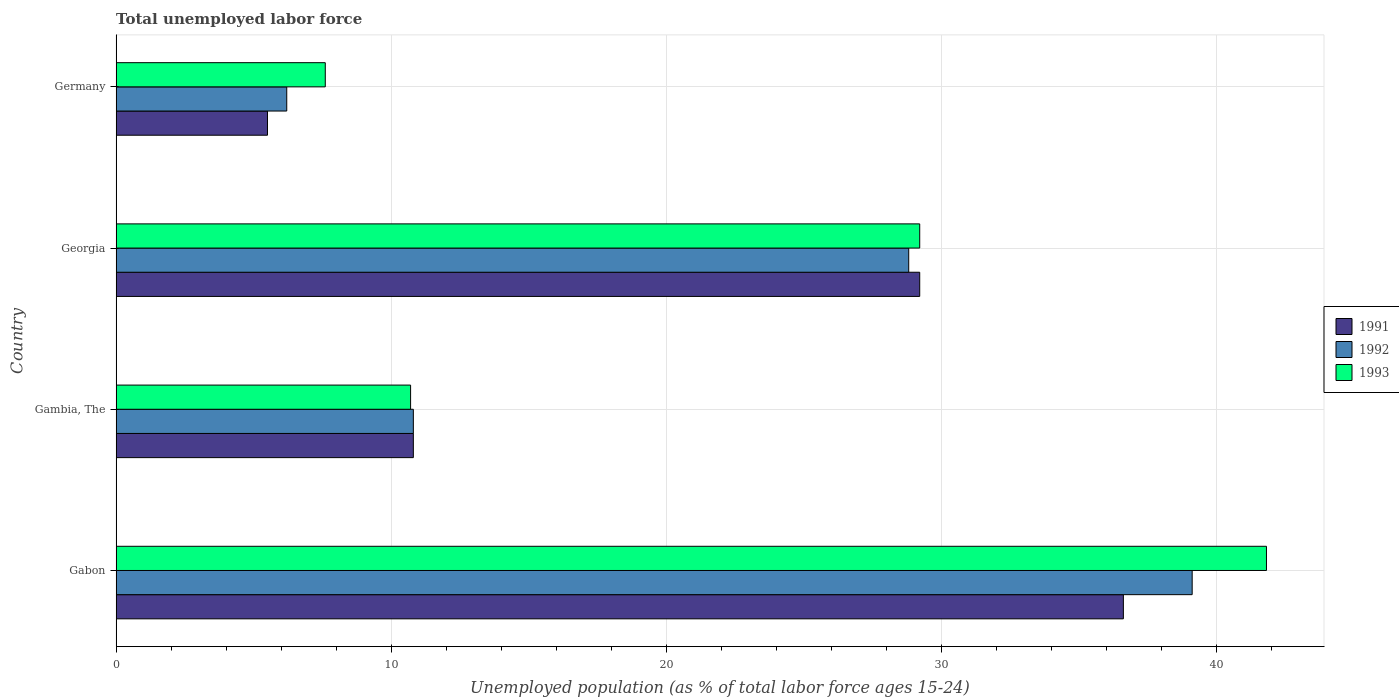How many groups of bars are there?
Your response must be concise. 4. Are the number of bars on each tick of the Y-axis equal?
Offer a very short reply. Yes. How many bars are there on the 4th tick from the top?
Your answer should be very brief. 3. What is the label of the 4th group of bars from the top?
Provide a short and direct response. Gabon. What is the percentage of unemployed population in in 1993 in Georgia?
Ensure brevity in your answer.  29.2. Across all countries, what is the maximum percentage of unemployed population in in 1991?
Ensure brevity in your answer.  36.6. In which country was the percentage of unemployed population in in 1992 maximum?
Your answer should be very brief. Gabon. In which country was the percentage of unemployed population in in 1992 minimum?
Provide a short and direct response. Germany. What is the total percentage of unemployed population in in 1993 in the graph?
Your answer should be very brief. 89.3. What is the difference between the percentage of unemployed population in in 1992 in Georgia and that in Germany?
Your response must be concise. 22.6. What is the difference between the percentage of unemployed population in in 1993 in Gambia, The and the percentage of unemployed population in in 1992 in Gabon?
Provide a short and direct response. -28.4. What is the average percentage of unemployed population in in 1991 per country?
Keep it short and to the point. 20.52. What is the difference between the percentage of unemployed population in in 1992 and percentage of unemployed population in in 1993 in Gambia, The?
Your answer should be very brief. 0.1. In how many countries, is the percentage of unemployed population in in 1993 greater than 40 %?
Provide a succinct answer. 1. What is the ratio of the percentage of unemployed population in in 1991 in Gambia, The to that in Georgia?
Provide a short and direct response. 0.37. Is the percentage of unemployed population in in 1991 in Gambia, The less than that in Georgia?
Give a very brief answer. Yes. What is the difference between the highest and the second highest percentage of unemployed population in in 1992?
Your answer should be very brief. 10.3. What is the difference between the highest and the lowest percentage of unemployed population in in 1993?
Provide a short and direct response. 34.2. In how many countries, is the percentage of unemployed population in in 1993 greater than the average percentage of unemployed population in in 1993 taken over all countries?
Your answer should be very brief. 2. What does the 2nd bar from the bottom in Germany represents?
Offer a terse response. 1992. Is it the case that in every country, the sum of the percentage of unemployed population in in 1991 and percentage of unemployed population in in 1993 is greater than the percentage of unemployed population in in 1992?
Provide a short and direct response. Yes. How many bars are there?
Provide a succinct answer. 12. Are all the bars in the graph horizontal?
Your answer should be compact. Yes. What is the difference between two consecutive major ticks on the X-axis?
Offer a very short reply. 10. Does the graph contain any zero values?
Provide a succinct answer. No. Where does the legend appear in the graph?
Offer a terse response. Center right. What is the title of the graph?
Offer a terse response. Total unemployed labor force. Does "2008" appear as one of the legend labels in the graph?
Offer a very short reply. No. What is the label or title of the X-axis?
Offer a terse response. Unemployed population (as % of total labor force ages 15-24). What is the label or title of the Y-axis?
Give a very brief answer. Country. What is the Unemployed population (as % of total labor force ages 15-24) in 1991 in Gabon?
Make the answer very short. 36.6. What is the Unemployed population (as % of total labor force ages 15-24) in 1992 in Gabon?
Provide a succinct answer. 39.1. What is the Unemployed population (as % of total labor force ages 15-24) in 1993 in Gabon?
Provide a short and direct response. 41.8. What is the Unemployed population (as % of total labor force ages 15-24) of 1991 in Gambia, The?
Keep it short and to the point. 10.8. What is the Unemployed population (as % of total labor force ages 15-24) of 1992 in Gambia, The?
Offer a terse response. 10.8. What is the Unemployed population (as % of total labor force ages 15-24) of 1993 in Gambia, The?
Your response must be concise. 10.7. What is the Unemployed population (as % of total labor force ages 15-24) of 1991 in Georgia?
Give a very brief answer. 29.2. What is the Unemployed population (as % of total labor force ages 15-24) of 1992 in Georgia?
Your answer should be compact. 28.8. What is the Unemployed population (as % of total labor force ages 15-24) of 1993 in Georgia?
Your answer should be compact. 29.2. What is the Unemployed population (as % of total labor force ages 15-24) of 1991 in Germany?
Offer a very short reply. 5.5. What is the Unemployed population (as % of total labor force ages 15-24) of 1992 in Germany?
Ensure brevity in your answer.  6.2. What is the Unemployed population (as % of total labor force ages 15-24) of 1993 in Germany?
Keep it short and to the point. 7.6. Across all countries, what is the maximum Unemployed population (as % of total labor force ages 15-24) of 1991?
Give a very brief answer. 36.6. Across all countries, what is the maximum Unemployed population (as % of total labor force ages 15-24) of 1992?
Your response must be concise. 39.1. Across all countries, what is the maximum Unemployed population (as % of total labor force ages 15-24) of 1993?
Keep it short and to the point. 41.8. Across all countries, what is the minimum Unemployed population (as % of total labor force ages 15-24) of 1992?
Offer a very short reply. 6.2. Across all countries, what is the minimum Unemployed population (as % of total labor force ages 15-24) in 1993?
Give a very brief answer. 7.6. What is the total Unemployed population (as % of total labor force ages 15-24) in 1991 in the graph?
Make the answer very short. 82.1. What is the total Unemployed population (as % of total labor force ages 15-24) in 1992 in the graph?
Keep it short and to the point. 84.9. What is the total Unemployed population (as % of total labor force ages 15-24) of 1993 in the graph?
Offer a very short reply. 89.3. What is the difference between the Unemployed population (as % of total labor force ages 15-24) of 1991 in Gabon and that in Gambia, The?
Your answer should be very brief. 25.8. What is the difference between the Unemployed population (as % of total labor force ages 15-24) in 1992 in Gabon and that in Gambia, The?
Provide a short and direct response. 28.3. What is the difference between the Unemployed population (as % of total labor force ages 15-24) in 1993 in Gabon and that in Gambia, The?
Ensure brevity in your answer.  31.1. What is the difference between the Unemployed population (as % of total labor force ages 15-24) in 1991 in Gabon and that in Georgia?
Your response must be concise. 7.4. What is the difference between the Unemployed population (as % of total labor force ages 15-24) in 1991 in Gabon and that in Germany?
Your answer should be very brief. 31.1. What is the difference between the Unemployed population (as % of total labor force ages 15-24) of 1992 in Gabon and that in Germany?
Your answer should be compact. 32.9. What is the difference between the Unemployed population (as % of total labor force ages 15-24) in 1993 in Gabon and that in Germany?
Give a very brief answer. 34.2. What is the difference between the Unemployed population (as % of total labor force ages 15-24) of 1991 in Gambia, The and that in Georgia?
Give a very brief answer. -18.4. What is the difference between the Unemployed population (as % of total labor force ages 15-24) in 1993 in Gambia, The and that in Georgia?
Your answer should be compact. -18.5. What is the difference between the Unemployed population (as % of total labor force ages 15-24) of 1991 in Gambia, The and that in Germany?
Provide a succinct answer. 5.3. What is the difference between the Unemployed population (as % of total labor force ages 15-24) of 1991 in Georgia and that in Germany?
Ensure brevity in your answer.  23.7. What is the difference between the Unemployed population (as % of total labor force ages 15-24) of 1992 in Georgia and that in Germany?
Your response must be concise. 22.6. What is the difference between the Unemployed population (as % of total labor force ages 15-24) of 1993 in Georgia and that in Germany?
Provide a succinct answer. 21.6. What is the difference between the Unemployed population (as % of total labor force ages 15-24) in 1991 in Gabon and the Unemployed population (as % of total labor force ages 15-24) in 1992 in Gambia, The?
Your response must be concise. 25.8. What is the difference between the Unemployed population (as % of total labor force ages 15-24) in 1991 in Gabon and the Unemployed population (as % of total labor force ages 15-24) in 1993 in Gambia, The?
Your response must be concise. 25.9. What is the difference between the Unemployed population (as % of total labor force ages 15-24) in 1992 in Gabon and the Unemployed population (as % of total labor force ages 15-24) in 1993 in Gambia, The?
Provide a succinct answer. 28.4. What is the difference between the Unemployed population (as % of total labor force ages 15-24) of 1991 in Gabon and the Unemployed population (as % of total labor force ages 15-24) of 1992 in Georgia?
Give a very brief answer. 7.8. What is the difference between the Unemployed population (as % of total labor force ages 15-24) of 1991 in Gabon and the Unemployed population (as % of total labor force ages 15-24) of 1993 in Georgia?
Keep it short and to the point. 7.4. What is the difference between the Unemployed population (as % of total labor force ages 15-24) of 1992 in Gabon and the Unemployed population (as % of total labor force ages 15-24) of 1993 in Georgia?
Make the answer very short. 9.9. What is the difference between the Unemployed population (as % of total labor force ages 15-24) in 1991 in Gabon and the Unemployed population (as % of total labor force ages 15-24) in 1992 in Germany?
Keep it short and to the point. 30.4. What is the difference between the Unemployed population (as % of total labor force ages 15-24) in 1992 in Gabon and the Unemployed population (as % of total labor force ages 15-24) in 1993 in Germany?
Your answer should be compact. 31.5. What is the difference between the Unemployed population (as % of total labor force ages 15-24) of 1991 in Gambia, The and the Unemployed population (as % of total labor force ages 15-24) of 1993 in Georgia?
Provide a short and direct response. -18.4. What is the difference between the Unemployed population (as % of total labor force ages 15-24) of 1992 in Gambia, The and the Unemployed population (as % of total labor force ages 15-24) of 1993 in Georgia?
Make the answer very short. -18.4. What is the difference between the Unemployed population (as % of total labor force ages 15-24) in 1991 in Gambia, The and the Unemployed population (as % of total labor force ages 15-24) in 1993 in Germany?
Provide a succinct answer. 3.2. What is the difference between the Unemployed population (as % of total labor force ages 15-24) in 1991 in Georgia and the Unemployed population (as % of total labor force ages 15-24) in 1992 in Germany?
Offer a very short reply. 23. What is the difference between the Unemployed population (as % of total labor force ages 15-24) of 1991 in Georgia and the Unemployed population (as % of total labor force ages 15-24) of 1993 in Germany?
Offer a terse response. 21.6. What is the difference between the Unemployed population (as % of total labor force ages 15-24) of 1992 in Georgia and the Unemployed population (as % of total labor force ages 15-24) of 1993 in Germany?
Keep it short and to the point. 21.2. What is the average Unemployed population (as % of total labor force ages 15-24) of 1991 per country?
Offer a terse response. 20.52. What is the average Unemployed population (as % of total labor force ages 15-24) in 1992 per country?
Make the answer very short. 21.23. What is the average Unemployed population (as % of total labor force ages 15-24) in 1993 per country?
Your response must be concise. 22.32. What is the difference between the Unemployed population (as % of total labor force ages 15-24) in 1991 and Unemployed population (as % of total labor force ages 15-24) in 1992 in Gabon?
Provide a short and direct response. -2.5. What is the difference between the Unemployed population (as % of total labor force ages 15-24) of 1991 and Unemployed population (as % of total labor force ages 15-24) of 1993 in Gabon?
Your answer should be very brief. -5.2. What is the difference between the Unemployed population (as % of total labor force ages 15-24) of 1991 and Unemployed population (as % of total labor force ages 15-24) of 1992 in Gambia, The?
Offer a terse response. 0. What is the difference between the Unemployed population (as % of total labor force ages 15-24) of 1992 and Unemployed population (as % of total labor force ages 15-24) of 1993 in Georgia?
Your answer should be very brief. -0.4. What is the difference between the Unemployed population (as % of total labor force ages 15-24) in 1991 and Unemployed population (as % of total labor force ages 15-24) in 1993 in Germany?
Offer a very short reply. -2.1. What is the difference between the Unemployed population (as % of total labor force ages 15-24) in 1992 and Unemployed population (as % of total labor force ages 15-24) in 1993 in Germany?
Make the answer very short. -1.4. What is the ratio of the Unemployed population (as % of total labor force ages 15-24) of 1991 in Gabon to that in Gambia, The?
Your answer should be very brief. 3.39. What is the ratio of the Unemployed population (as % of total labor force ages 15-24) in 1992 in Gabon to that in Gambia, The?
Your response must be concise. 3.62. What is the ratio of the Unemployed population (as % of total labor force ages 15-24) in 1993 in Gabon to that in Gambia, The?
Offer a very short reply. 3.91. What is the ratio of the Unemployed population (as % of total labor force ages 15-24) of 1991 in Gabon to that in Georgia?
Provide a short and direct response. 1.25. What is the ratio of the Unemployed population (as % of total labor force ages 15-24) in 1992 in Gabon to that in Georgia?
Give a very brief answer. 1.36. What is the ratio of the Unemployed population (as % of total labor force ages 15-24) in 1993 in Gabon to that in Georgia?
Your answer should be compact. 1.43. What is the ratio of the Unemployed population (as % of total labor force ages 15-24) of 1991 in Gabon to that in Germany?
Offer a very short reply. 6.65. What is the ratio of the Unemployed population (as % of total labor force ages 15-24) of 1992 in Gabon to that in Germany?
Offer a terse response. 6.31. What is the ratio of the Unemployed population (as % of total labor force ages 15-24) in 1993 in Gabon to that in Germany?
Provide a succinct answer. 5.5. What is the ratio of the Unemployed population (as % of total labor force ages 15-24) in 1991 in Gambia, The to that in Georgia?
Offer a very short reply. 0.37. What is the ratio of the Unemployed population (as % of total labor force ages 15-24) in 1993 in Gambia, The to that in Georgia?
Provide a succinct answer. 0.37. What is the ratio of the Unemployed population (as % of total labor force ages 15-24) of 1991 in Gambia, The to that in Germany?
Provide a succinct answer. 1.96. What is the ratio of the Unemployed population (as % of total labor force ages 15-24) in 1992 in Gambia, The to that in Germany?
Offer a terse response. 1.74. What is the ratio of the Unemployed population (as % of total labor force ages 15-24) in 1993 in Gambia, The to that in Germany?
Keep it short and to the point. 1.41. What is the ratio of the Unemployed population (as % of total labor force ages 15-24) in 1991 in Georgia to that in Germany?
Ensure brevity in your answer.  5.31. What is the ratio of the Unemployed population (as % of total labor force ages 15-24) of 1992 in Georgia to that in Germany?
Your response must be concise. 4.65. What is the ratio of the Unemployed population (as % of total labor force ages 15-24) of 1993 in Georgia to that in Germany?
Keep it short and to the point. 3.84. What is the difference between the highest and the second highest Unemployed population (as % of total labor force ages 15-24) in 1991?
Make the answer very short. 7.4. What is the difference between the highest and the second highest Unemployed population (as % of total labor force ages 15-24) in 1992?
Your answer should be very brief. 10.3. What is the difference between the highest and the lowest Unemployed population (as % of total labor force ages 15-24) in 1991?
Provide a succinct answer. 31.1. What is the difference between the highest and the lowest Unemployed population (as % of total labor force ages 15-24) of 1992?
Keep it short and to the point. 32.9. What is the difference between the highest and the lowest Unemployed population (as % of total labor force ages 15-24) of 1993?
Your answer should be compact. 34.2. 